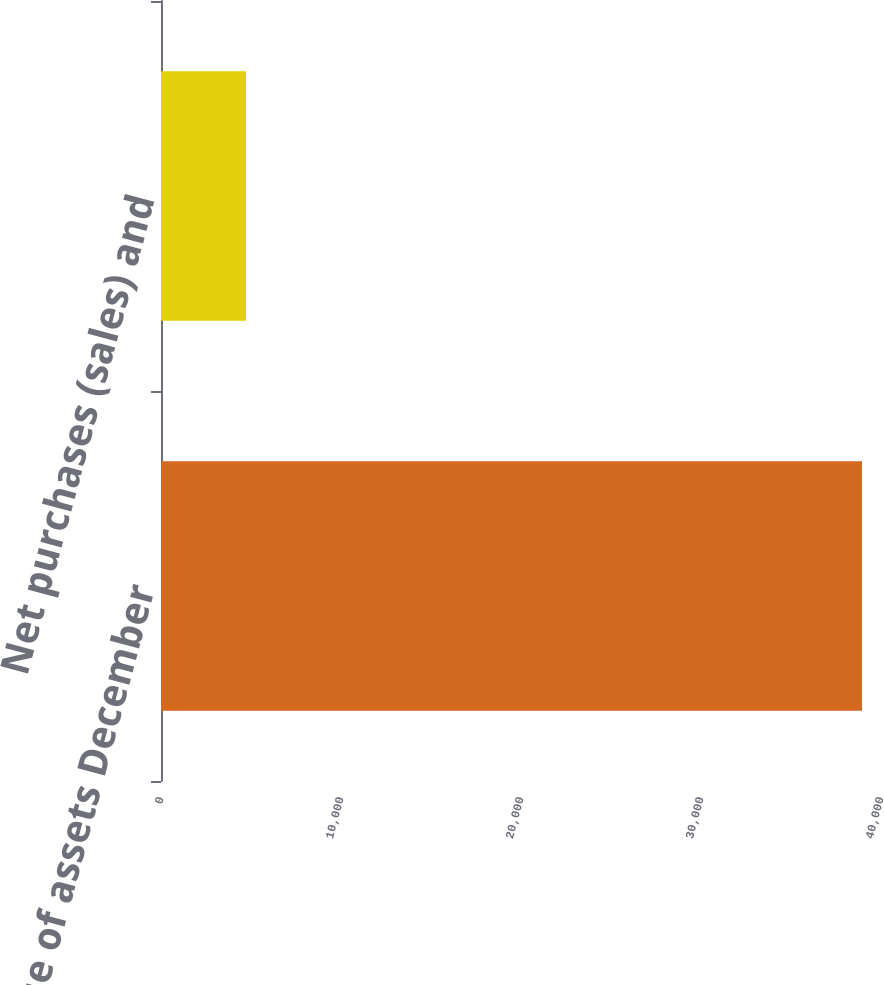<chart> <loc_0><loc_0><loc_500><loc_500><bar_chart><fcel>Fair value of assets December<fcel>Net purchases (sales) and<nl><fcel>38943<fcel>4723<nl></chart> 